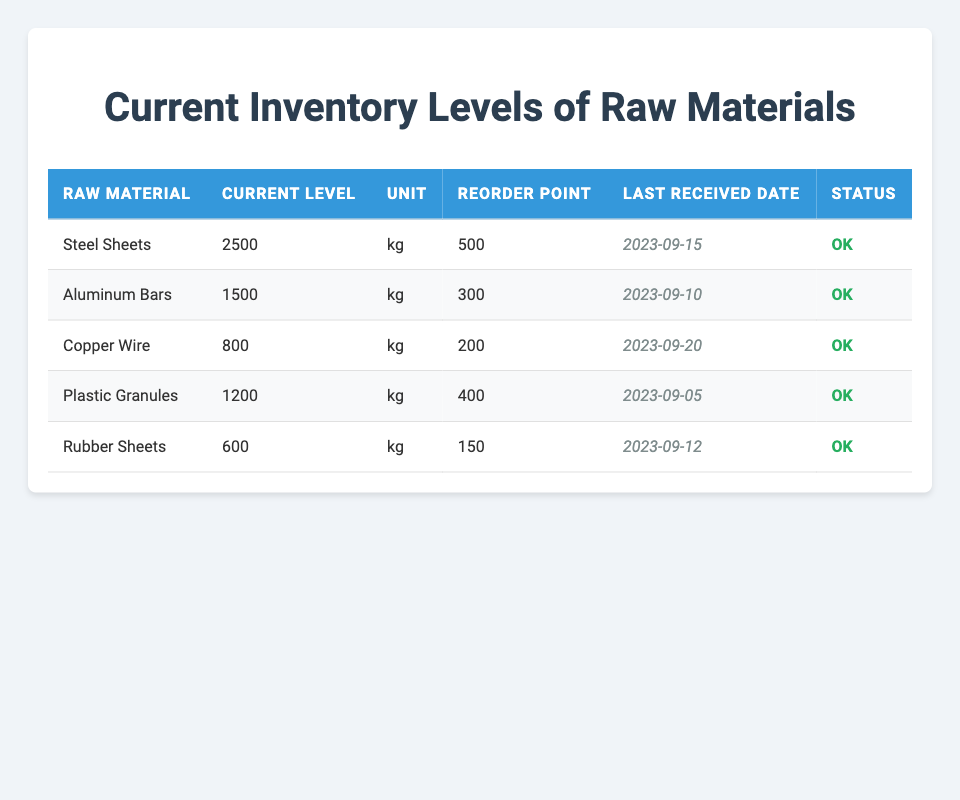What is the current level of Steel Sheets? The table lists the current level of Steel Sheets under the "Current Level" column, which reads "2500 kg".
Answer: 2500 kg What is the reorder point for Copper Wire? The reorder point for Copper Wire is found in the "Reorder Point" column next to Copper Wire in the table, which states "200".
Answer: 200 How many raw materials have a current inventory level above 1000 kg? By examining the "Current Level" column, we see that Steel Sheets (2500 kg), Aluminum Bars (1500 kg), and Plastic Granules (1200 kg) have levels above 1000 kg. Counting these entries results in 3 raw materials.
Answer: 3 Which raw material was last received on 2023-09-20? Consulting the "Last Received Date" column, we find that Copper Wire is listed with the date "2023-09-20", indicating it is the last received material on that date.
Answer: Copper Wire What is the total current inventory level of all raw materials? To find the total inventory, we add the current levels: Steel Sheets (2500 kg) + Aluminum Bars (1500 kg) + Copper Wire (800 kg) + Plastic Granules (1200 kg) + Rubber Sheets (600 kg) = 2500 + 1500 + 800 + 1200 + 600 = 5600 kg.
Answer: 5600 kg Is the current level of Rubber Sheets below its reorder point? The current level of Rubber Sheets is 600 kg, and the reorder point is 150. Since 600 is greater than 150, the statement is false.
Answer: No What is the average current level of materials that have a reorder point below 300 kg? The only material with a reorder point below 300 kg is Rubber Sheets (150 kg). Since there is only one material, the average is the same as its current level, which is 600 kg.
Answer: 600 kg How many raw materials are marked as 'OK' in terms of their inventory status? The status for all materials listed in the table is "OK", which amounts to 5 materials.
Answer: 5 What is the difference between the current levels of Aluminum Bars and Copper Wire? The current level of Aluminum Bars is 1500 kg and for Copper Wire, it is 800 kg. The difference is calculated as 1500 kg - 800 kg = 700 kg.
Answer: 700 kg 